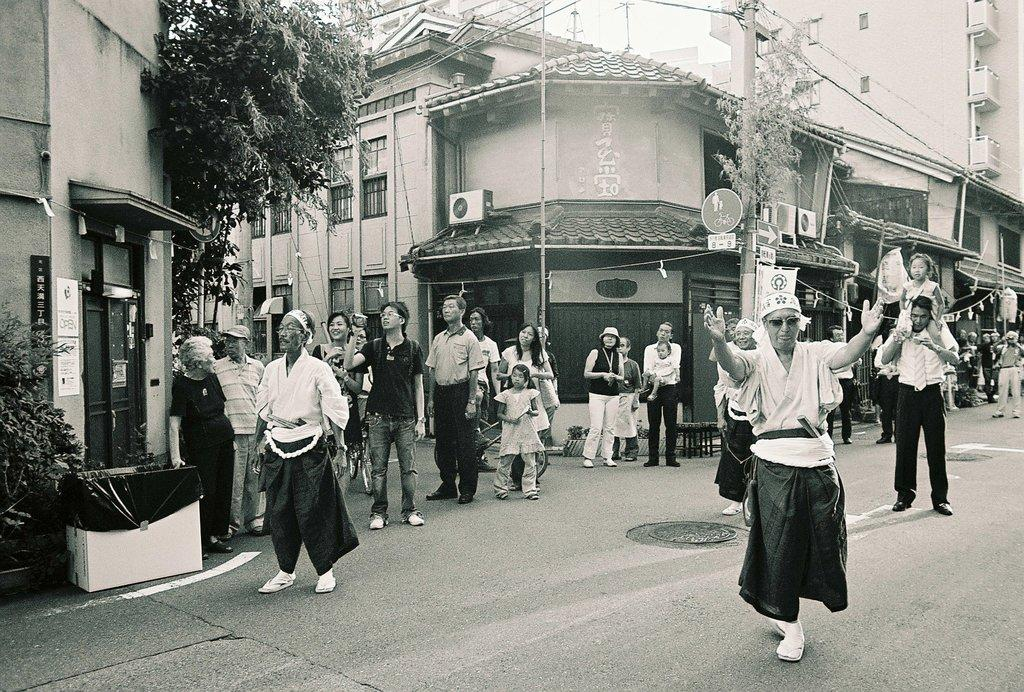What is the color scheme of the image? The image is black and white. What can be seen in the image besides the color scheme? There are people standing in the image, including a person in motion. What type of structures are visible in the image? There are buildings visible in the image. What else can be seen in the image? There is a pole with wires and plants on the left side of the image. Can you see any cobwebs in the image? There are no cobwebs visible in the image. What team is responsible for maintaining the buildings in the image? The image does not provide information about any team responsible for maintaining the buildings. 